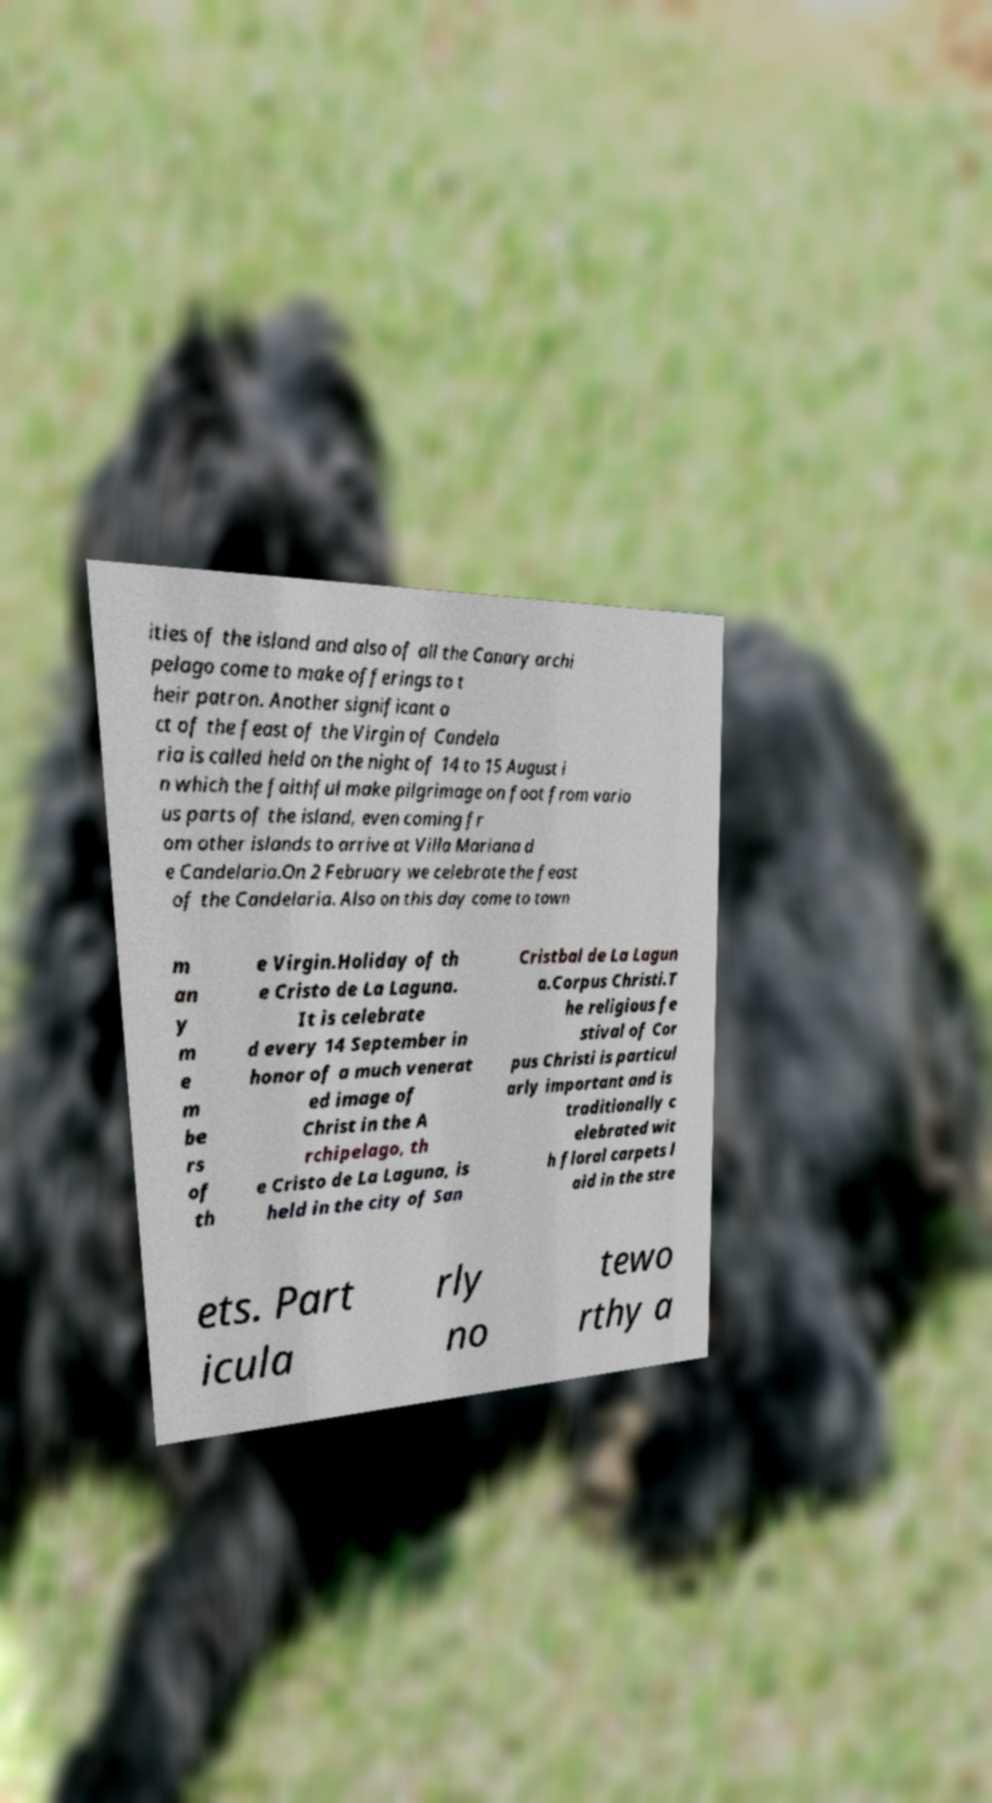I need the written content from this picture converted into text. Can you do that? ities of the island and also of all the Canary archi pelago come to make offerings to t heir patron. Another significant a ct of the feast of the Virgin of Candela ria is called held on the night of 14 to 15 August i n which the faithful make pilgrimage on foot from vario us parts of the island, even coming fr om other islands to arrive at Villa Mariana d e Candelaria.On 2 February we celebrate the feast of the Candelaria. Also on this day come to town m an y m e m be rs of th e Virgin.Holiday of th e Cristo de La Laguna. It is celebrate d every 14 September in honor of a much venerat ed image of Christ in the A rchipelago, th e Cristo de La Laguna, is held in the city of San Cristbal de La Lagun a.Corpus Christi.T he religious fe stival of Cor pus Christi is particul arly important and is traditionally c elebrated wit h floral carpets l aid in the stre ets. Part icula rly no tewo rthy a 